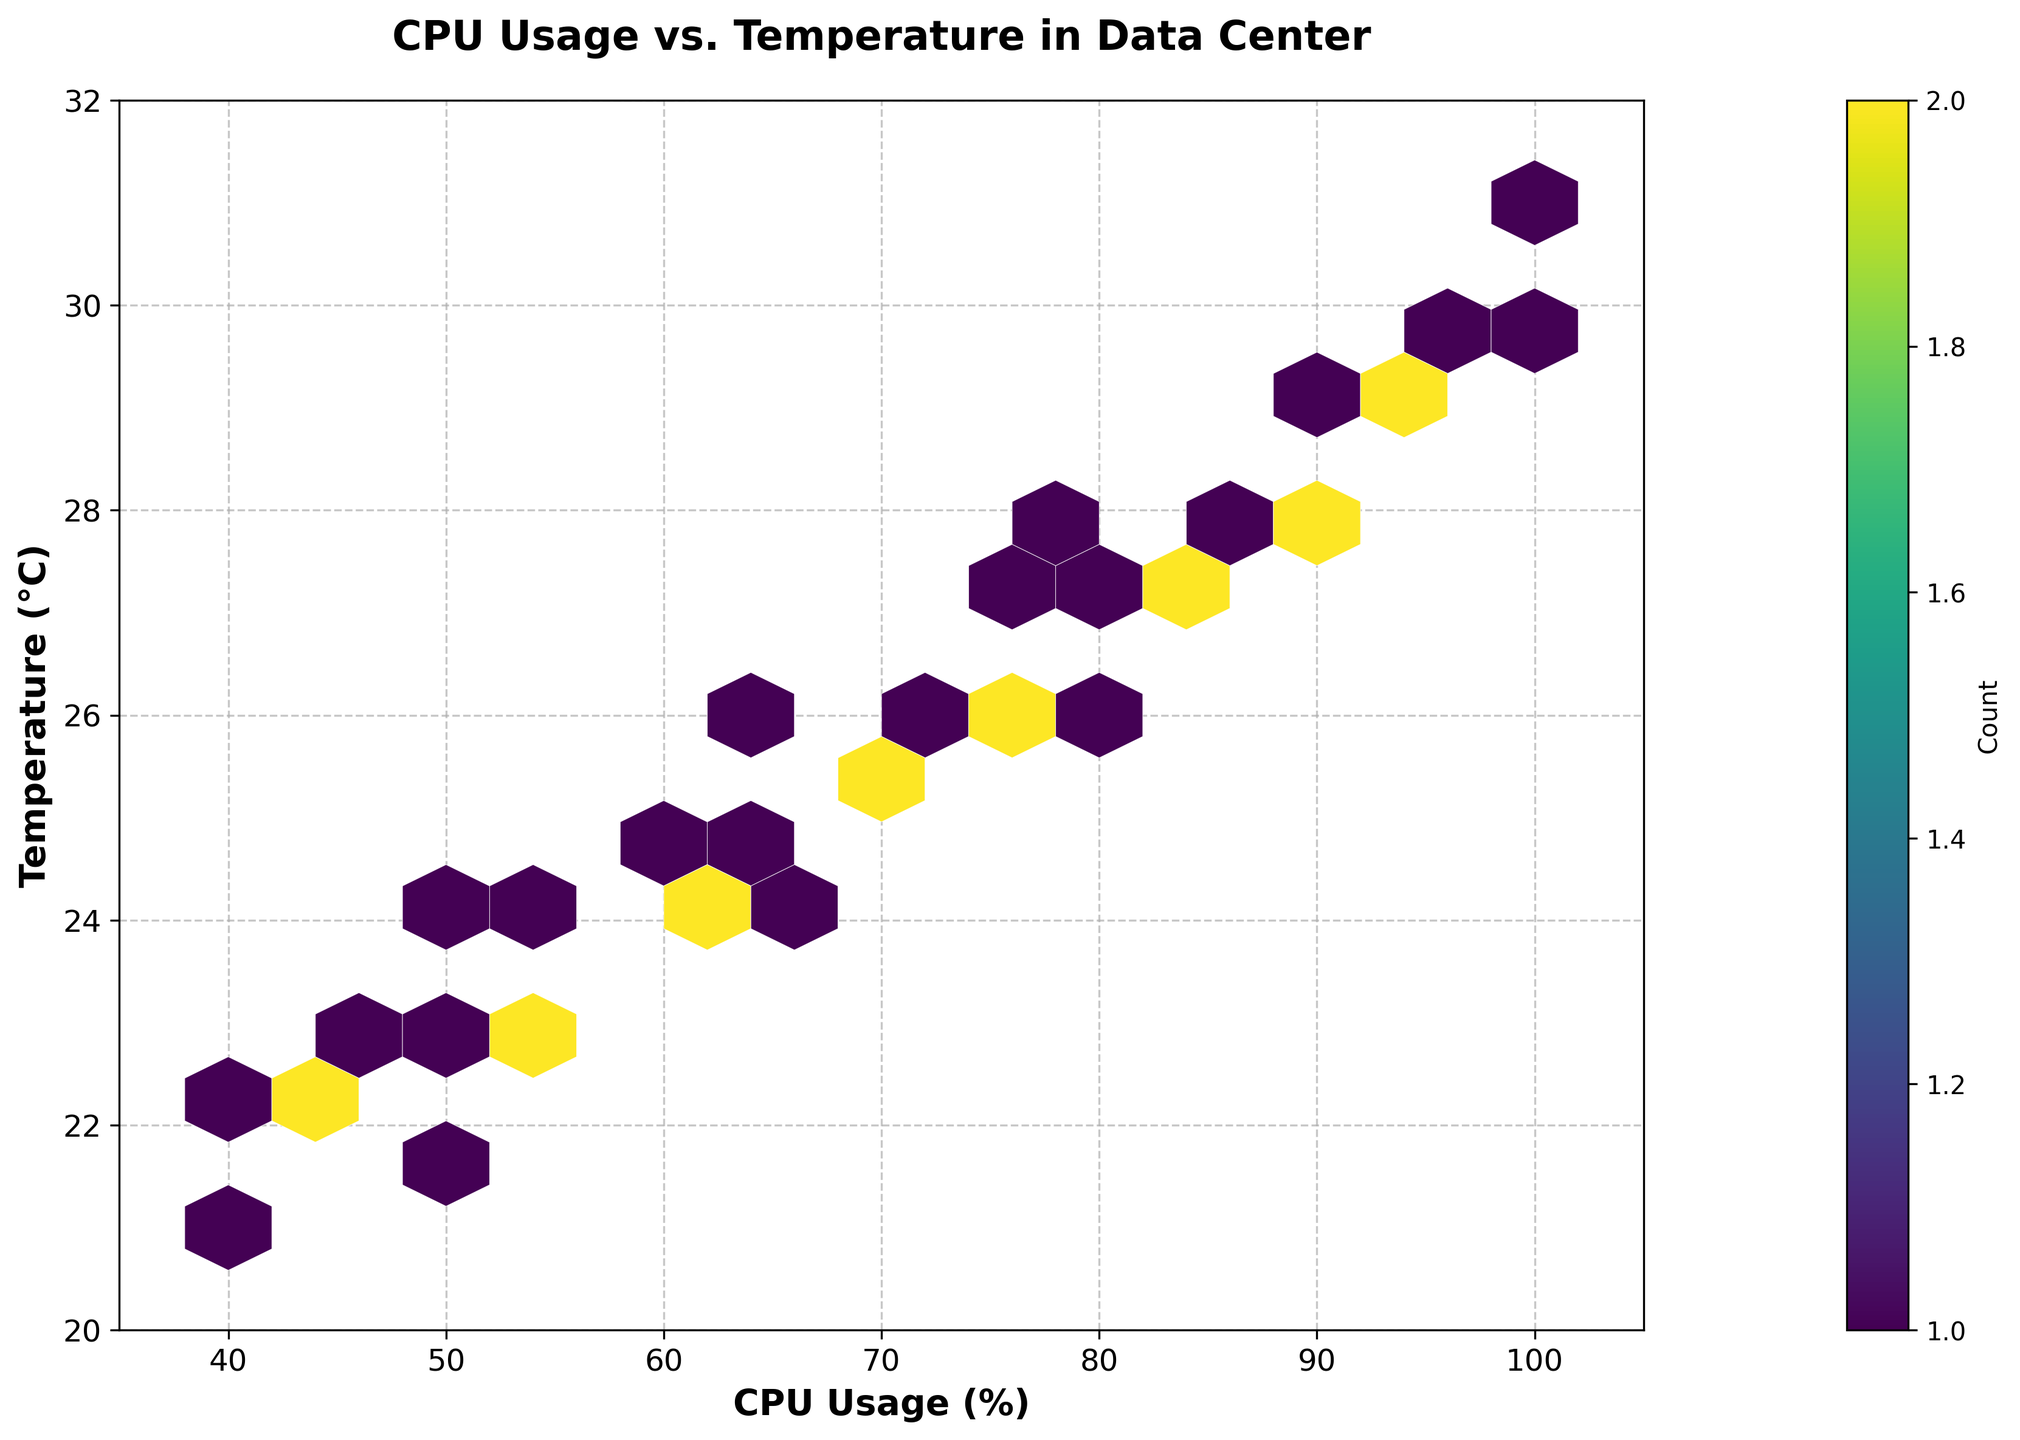1. What is the title of the figure? The title of the figure is displayed at the top of the plot. By looking at it, we can see it is "CPU Usage vs. Temperature in Data Center".
Answer: CPU Usage vs. Temperature in Data Center 2. What are the labels of the x-axis and y-axis? The labels for the axes can be seen directly below the x-axis and beside the y-axis. The x-axis is labeled "CPU Usage (%)" and the y-axis is labeled "Temperature (°C)".
Answer: CPU Usage (%), Temperature (°C) 3. What color represents the highest frequency of data points? The color bar on the right-hand side of the plot indicates the frequency of data points. The highest frequency is represented by the darkest color on the viridis color scale.
Answer: Dark Purple 4. What is the range of the x-axis and y-axis? The range of the x-axis can be observed from its limits, going from 35 to 105. Similarly, the y-axis ranges from 20 to 32. This information is apparent through the tick marks and axis limits.
Answer: 35 to 105, 20 to 32 5. Are there more data points with CPU usage above 75% or below 75%? By looking at the density of hexagonal bins and their colors around the CPU usage value of 75%, it's evident if more data points are distributed above or below this value. The darker clusters around these values give a clue.
Answer: Above 75% 6. What's the general relationship between CPU usage and temperature? Generally, hexbin plots show the density of data points. If higher CPU usage correlates with increased temperature, we'd observe denser clusters (darker colors) moving in an upward right direction.
Answer: Positive correlation 7. Which CPU usage and temperature range contains the highest concentration of data points? The highest concentration can be identified by the darkest colored bin. By noting the center coordinates of this bin, we find the approximate CPU usage and temperature range.
Answer: CPU usage around 60-70%, Temperature around 24-25°C 8. How does the temperature vary when CPU usage is between 75% and 90%? By examining the density and color gradient of the hexagons in the region where CPU usage is between 75% and 90%, we can see how the temperature values range in that area. Look at the vertical placement of the hexagons within these horizontal limits.
Answer: Temperature varies from 26°C to 29°C 9. Is there any evident outlier in the data? Outliers in a hexbin plot can be identified by sparse or isolated hexagonal bins that do not conform to the general data concentration pattern. Inspect the plot for any lone bins far away from the dense clusters.
Answer: No evident outlier 10. What is the frequency count of the most common data point? The most common data point is represented by the darkest hexbin. The color bar on the right indicates the frequency count associated with the darkest shade. By matching this color to the scale, we can determine the count.
Answer: Based on the color bar, the most common data point has a count of around 4 (darkest bins) 